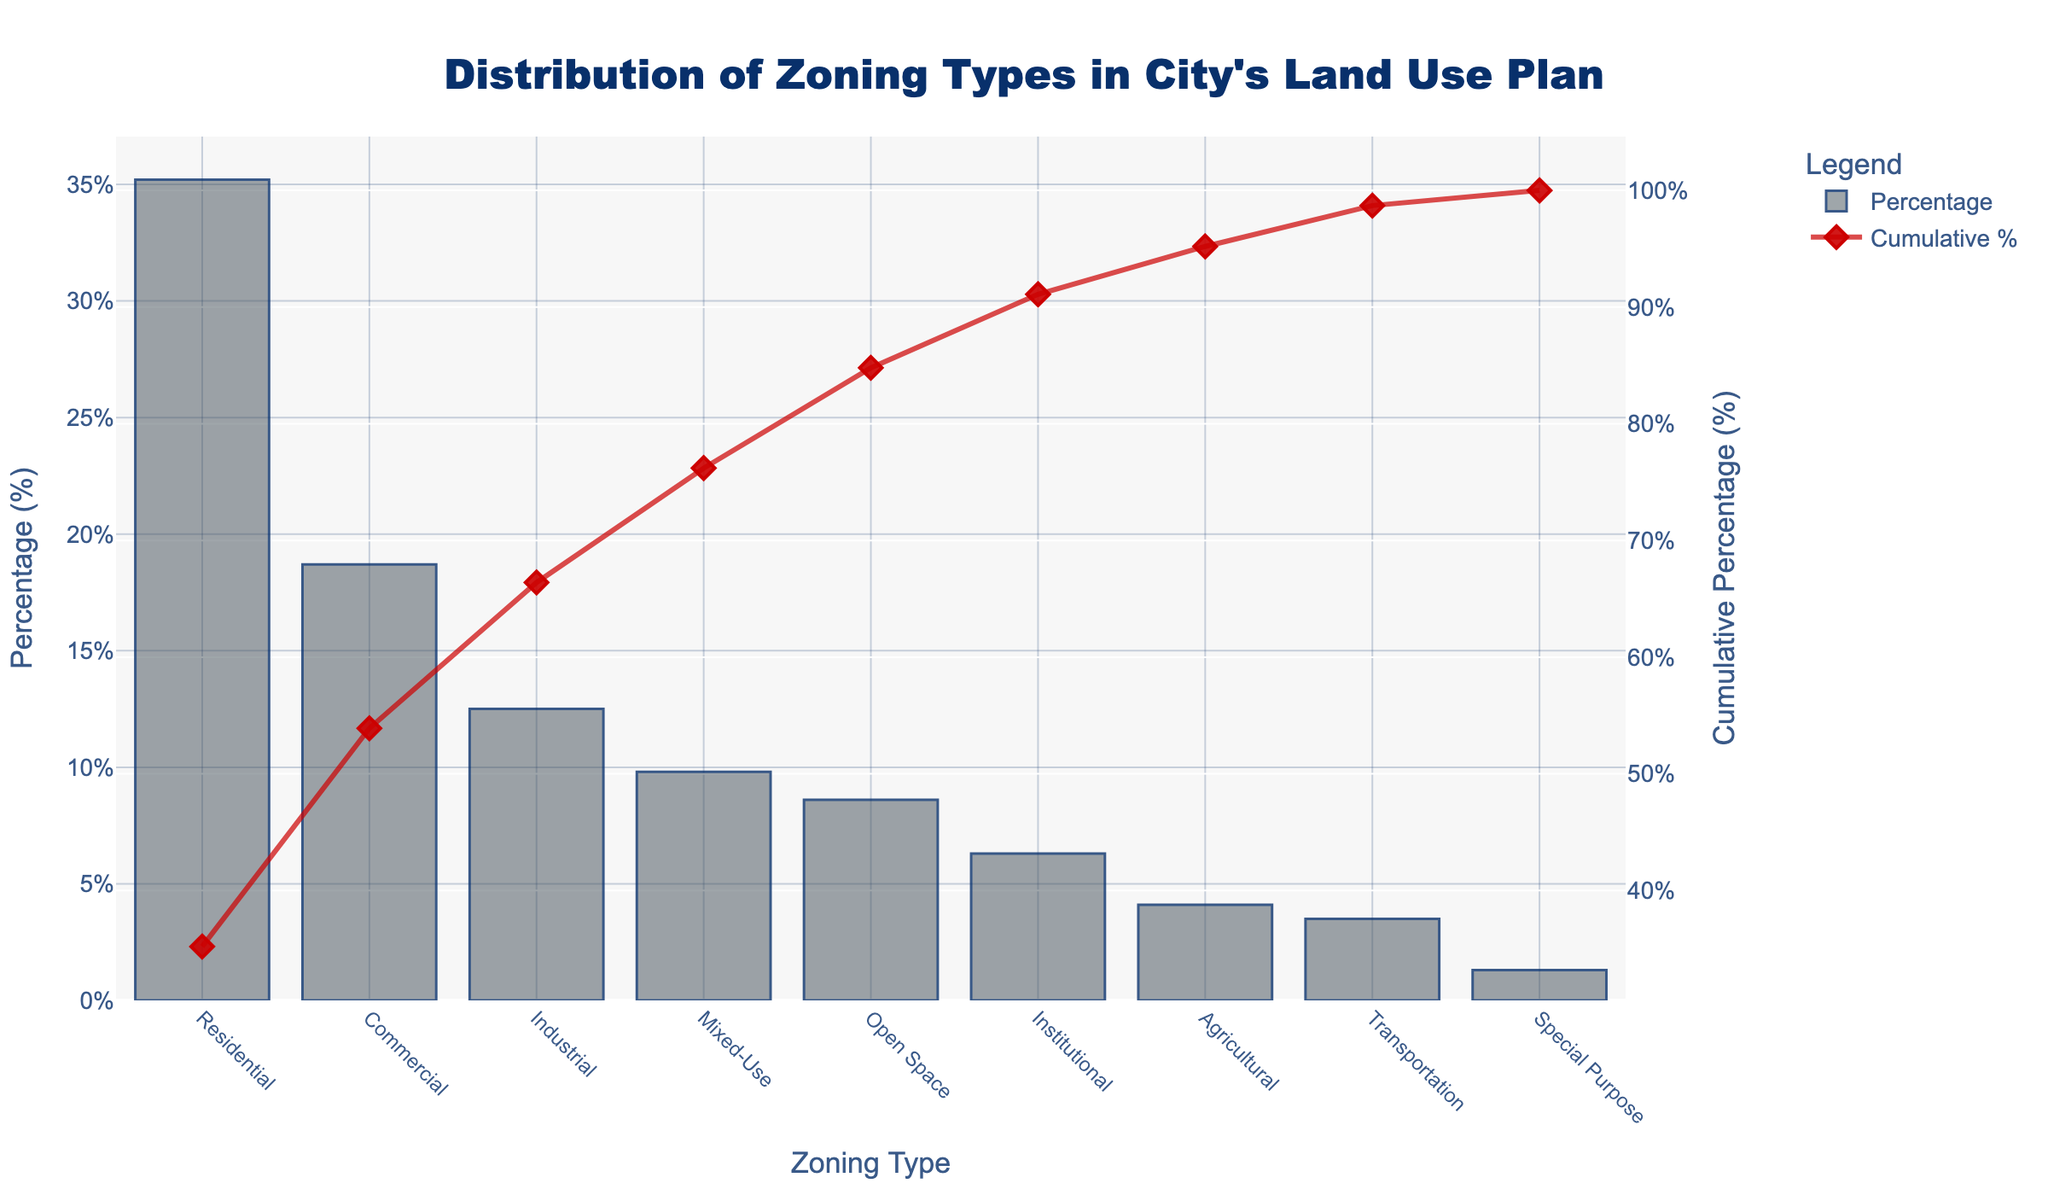Which zoning type has the highest percentage? The bar chart shows the heights of the bars corresponding to different zoning types. The tallest bar represents the zoning type with the highest percentage. The Residential zoning type has the highest percentage at 35.2%.
Answer: Residential Which zoning type has the lowest percentage? The shortest bar in the chart represents the zoning type with the lowest percentage. The Special Purpose zoning type has the lowest percentage at 1.3%.
Answer: Special Purpose What is the combined percentage for Residential and Commercial zoning types? To find the combined percentage, we add the percentages of Residential and Commercial zoning types. Residential is 35.2% and Commercial is 18.7%. 35.2 + 18.7 = 53.9%.
Answer: 53.9% Which zoning types have a percentage greater than 10%? We need to identify bars that reach above the 10% mark on the y-axis. Residential (35.2%), Commercial (18.7%), and Industrial (12.5%) all have percentages greater than 10%.
Answer: Residential, Commercial, Industrial What is the difference in percentage between Industrial and Agricultural zoning types? The percentage for Industrial zoning is 12.5%, and for Agricultural, it is 4.1%. The difference is calculated as 12.5 - 4.1 = 8.4%.
Answer: 8.4% Which zoning types cumulatively make up about 50% of the city's land use? We refer to the cumulative percentage line on the chart. Adding the percentages from the highest, Residential (35.2%) and Commercial (18.7%), we reach a cumulative percentage of 53.9%, indicating these two types make up approximately 50%.
Answer: Residential, Commercial How does the percentage of Open Space compare to that of Institutional zoning? The heights of the bars representing Open Space and Institutional zoning types need to be compared. Open Space (8.6%) is slightly higher than Institutional (6.3%).
Answer: Open Space is higher What is the cumulative percentage after including Mixed-Use zoning type? To find the cumulative percentage after including the Mixed-Use zoning type, we add its percentage to the sum of all higher percentages: Residential (35.2%) + Commercial (18.7%) + Industrial (12.5%) + Mixed-Use (9.8%). This totals to 76.2%.
Answer: 76.2% Are there more zoning types with a percentage below 5% or above 15%? We count the number of zoning types below and above the specified percentages. Below 5%: Agricultural (4.1%), Transportation (3.5%), Special Purpose (1.3%) — 3 types. Above 15%: Residential (35.2%), Commercial (18.7%) — 2 types. There are more zoning types with a percentage below 5%.
Answer: More below 5% Which zoning type has the closest percentage to Mixed-Use? To determine proximity, compare the Mixed-Use zoning percentage (9.8%) with other percentages. The closest is Open Space at 8.6%, with a difference of 1.2%.
Answer: Open Space 